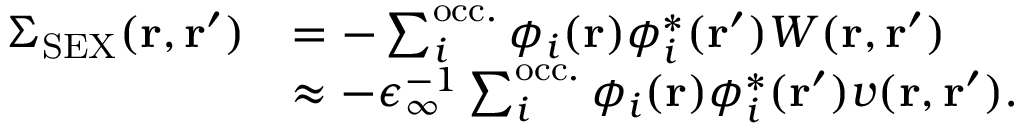<formula> <loc_0><loc_0><loc_500><loc_500>\begin{array} { r l } { \Sigma _ { S E X } ( r , r ^ { \prime } ) } & { = - \sum _ { i } ^ { o c c . } \phi _ { i } ( r ) \phi _ { i } ^ { * } ( r ^ { \prime } ) W ( r , r ^ { \prime } ) } \\ & { \approx - \epsilon _ { \infty } ^ { - 1 } \sum _ { i } ^ { o c c . } \phi _ { i } ( r ) \phi _ { i } ^ { * } ( r ^ { \prime } ) v ( r , r ^ { \prime } ) . } \end{array}</formula> 